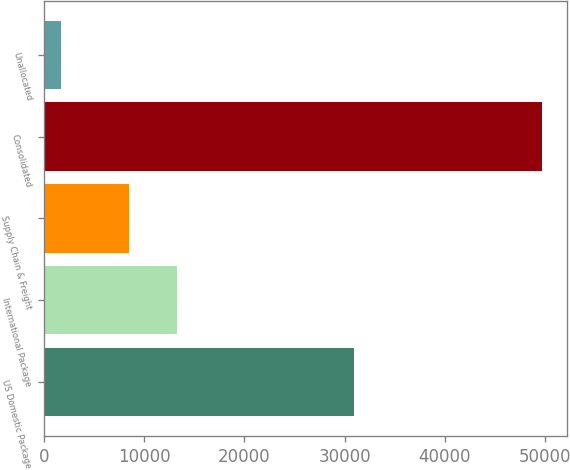Convert chart. <chart><loc_0><loc_0><loc_500><loc_500><bar_chart><fcel>US Domestic Package<fcel>International Package<fcel>Supply Chain & Freight<fcel>Consolidated<fcel>Unallocated<nl><fcel>30985<fcel>13226.6<fcel>8426<fcel>49692<fcel>1686<nl></chart> 